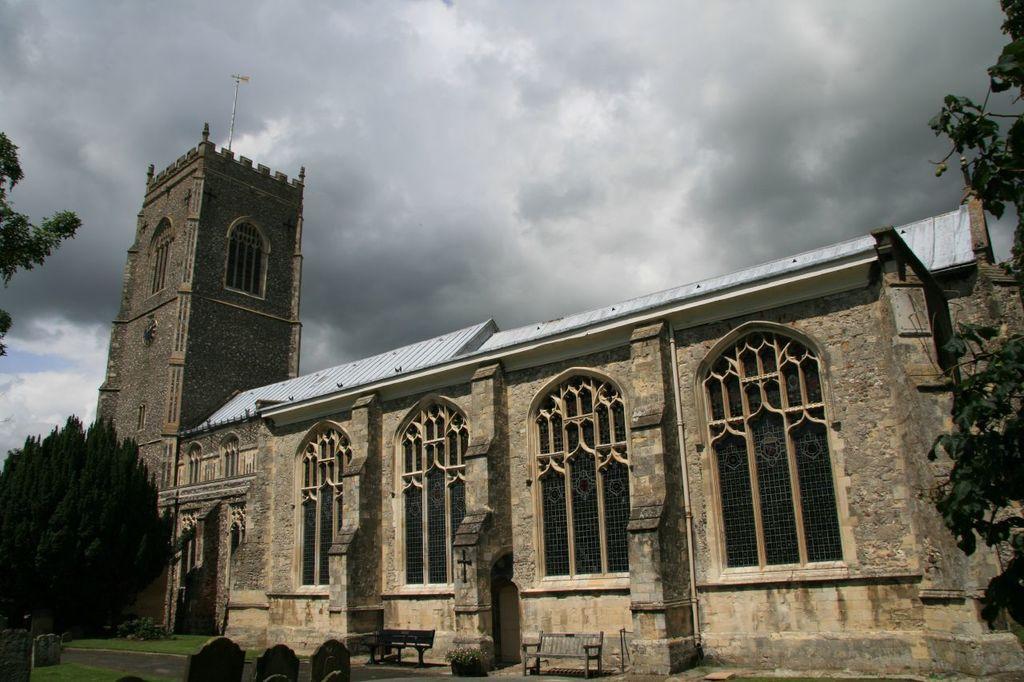How would you summarize this image in a sentence or two? In the foreground of the image we can see some benches placed on the ground. In the center of the image we can see a building with a group of windows, tower and roof. In the background, we can see a group of trees and the cloudy sky. 